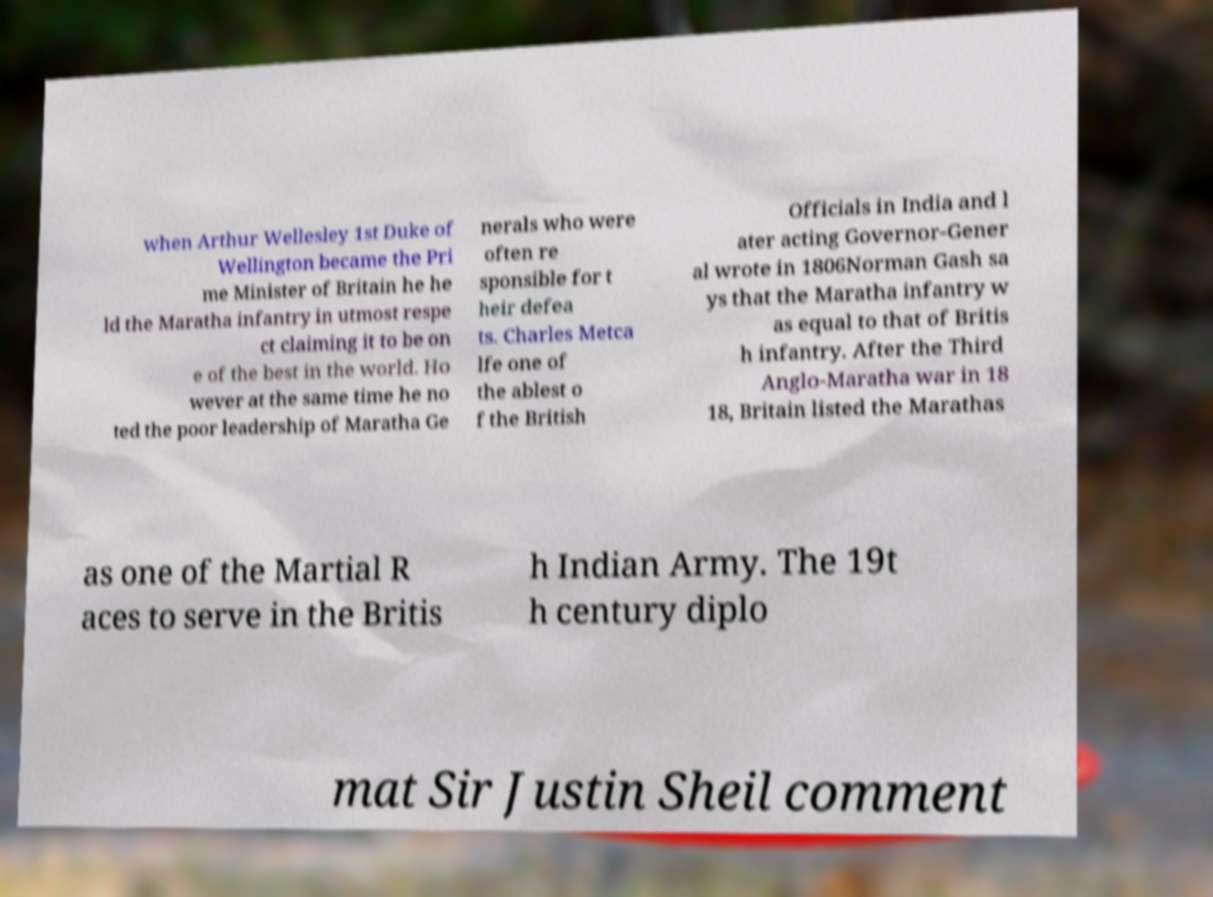Can you read and provide the text displayed in the image?This photo seems to have some interesting text. Can you extract and type it out for me? when Arthur Wellesley 1st Duke of Wellington became the Pri me Minister of Britain he he ld the Maratha infantry in utmost respe ct claiming it to be on e of the best in the world. Ho wever at the same time he no ted the poor leadership of Maratha Ge nerals who were often re sponsible for t heir defea ts. Charles Metca lfe one of the ablest o f the British Officials in India and l ater acting Governor-Gener al wrote in 1806Norman Gash sa ys that the Maratha infantry w as equal to that of Britis h infantry. After the Third Anglo-Maratha war in 18 18, Britain listed the Marathas as one of the Martial R aces to serve in the Britis h Indian Army. The 19t h century diplo mat Sir Justin Sheil comment 